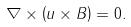<formula> <loc_0><loc_0><loc_500><loc_500>\nabla \times \left ( { u } \times { B } \right ) = 0 .</formula> 